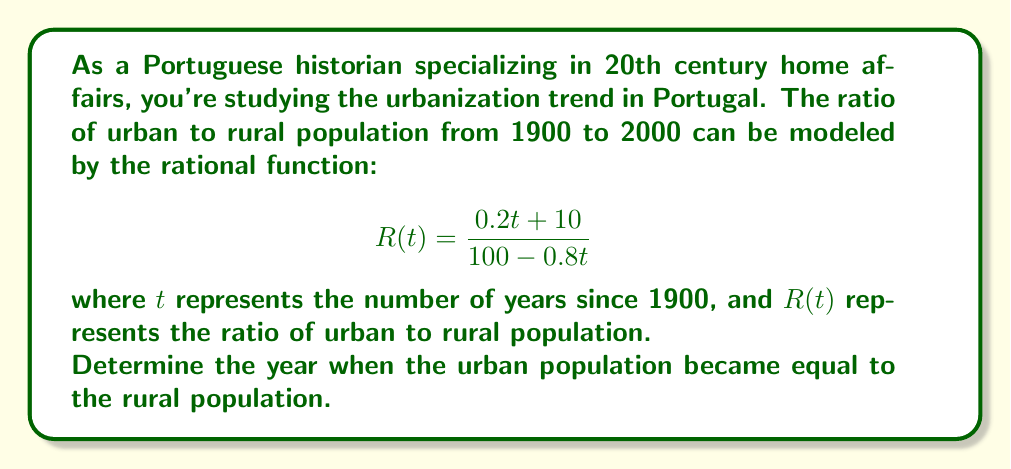Can you answer this question? To solve this problem, we need to follow these steps:

1) When the urban population equals the rural population, their ratio is 1:1, or simply 1.

2) We need to find $t$ when $R(t) = 1$:

   $$\frac{0.2t + 10}{100 - 0.8t} = 1$$

3) Cross-multiply to clear the fraction:

   $$(0.2t + 10) = (100 - 0.8t)$$

4) Expand the brackets:

   $$0.2t + 10 = 100 - 0.8t$$

5) Add $0.8t$ to both sides:

   $$t + 10 = 100 - 0.8t$$

6) Add $0.8t$ to both sides:

   $$1.8t + 10 = 100$$

7) Subtract 10 from both sides:

   $$1.8t = 90$$

8) Divide both sides by 1.8:

   $$t = 50$$

9) Recall that $t$ represents years since 1900, so add 1900 to get the actual year:

   1900 + 50 = 1950

Therefore, the urban population became equal to the rural population in 1950.
Answer: 1950 